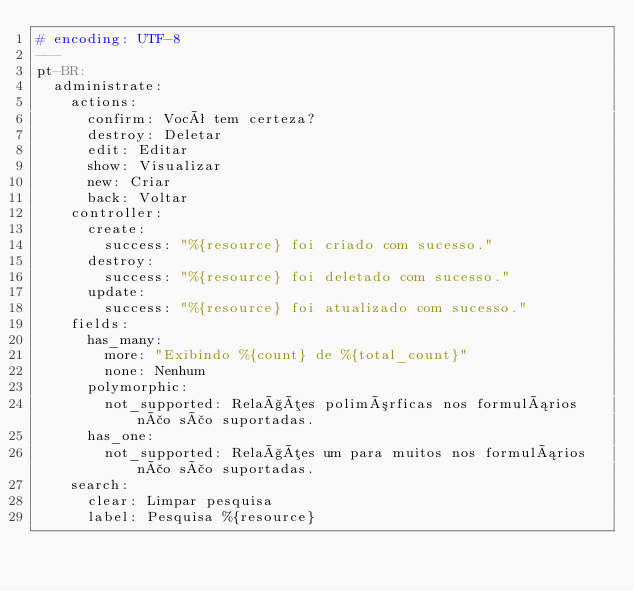Convert code to text. <code><loc_0><loc_0><loc_500><loc_500><_YAML_># encoding: UTF-8
---
pt-BR:
  administrate:
    actions:
      confirm: Você tem certeza?
      destroy: Deletar
      edit: Editar
      show: Visualizar
      new: Criar
      back: Voltar
    controller:
      create:
        success: "%{resource} foi criado com sucesso."
      destroy:
        success: "%{resource} foi deletado com sucesso."
      update:
        success: "%{resource} foi atualizado com sucesso."
    fields:
      has_many:
        more: "Exibindo %{count} de %{total_count}"
        none: Nenhum
      polymorphic:
        not_supported: Relações polimórficas nos formulários não são suportadas.
      has_one:
        not_supported: Relações um para muitos nos formulários não são suportadas.
    search:
      clear: Limpar pesquisa
      label: Pesquisa %{resource}
</code> 